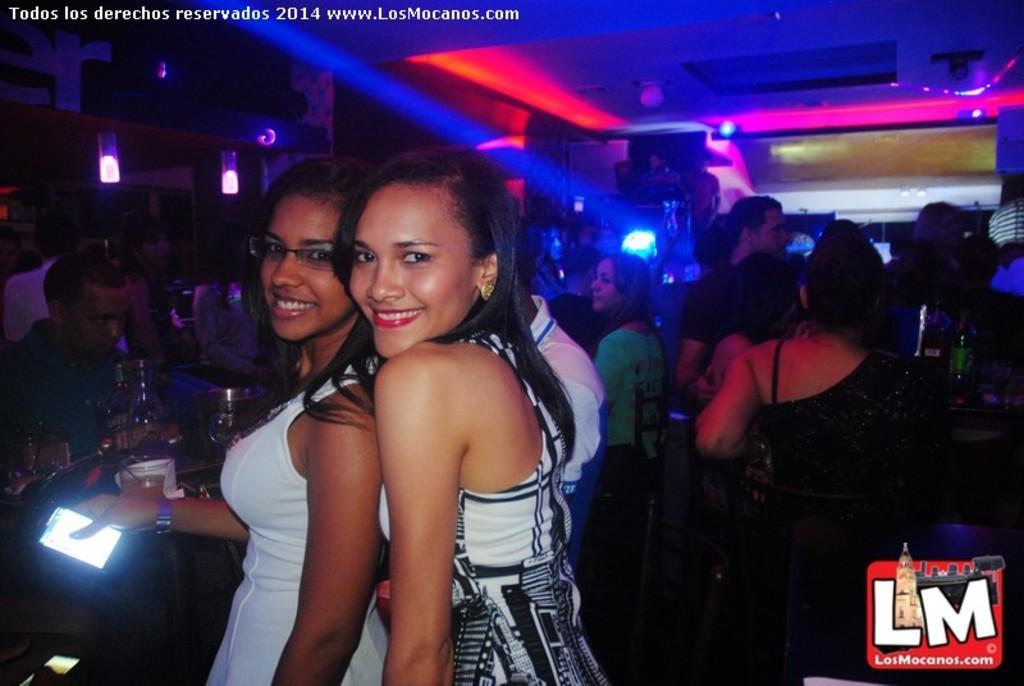Describe this image in one or two sentences. In this image I can see some people. On the left side I can see some objects on the table. At the top I can see the lights. 